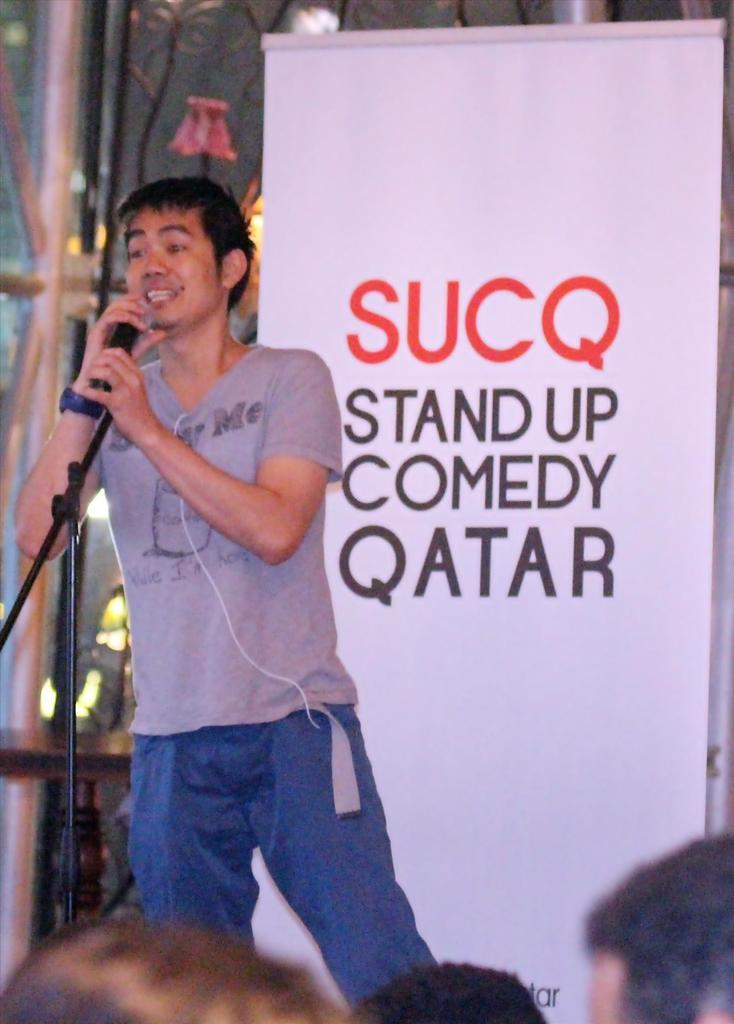What is the man in the image doing? The man is singing on a microphone. What can be seen in the background of the image? There is a banner in the background of the image. Are there any other people present in the image? Yes, there are people visible in the image. What is the purpose of the light in the image? The light might be used to illuminate the stage or the performer. What type of plane can be seen flying in the image? There is no plane visible in the image; it features a man singing on a microphone. What design or curve can be seen on the microphone in the image? The microphone in the image does not have any visible design or curve. 